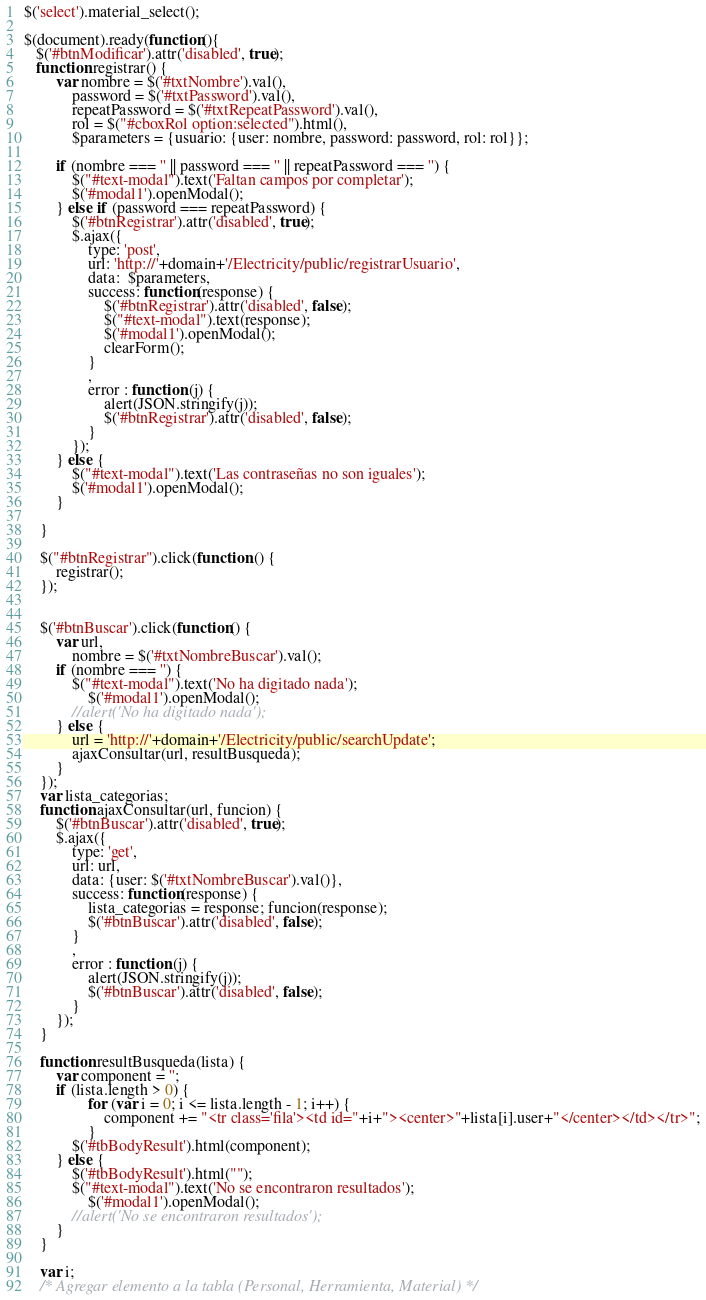Convert code to text. <code><loc_0><loc_0><loc_500><loc_500><_JavaScript_>$('select').material_select();

$(document).ready(function(){
   $('#btnModificar').attr('disabled', true);
   function registrar() {
        var nombre = $('#txtNombre').val(),
            password = $('#txtPassword').val(),
            repeatPassword = $('#txtRepeatPassword').val(),
            rol = $("#cboxRol option:selected").html(),
            $parameters = {usuario: {user: nombre, password: password, rol: rol}};
        
        if (nombre === '' || password === '' || repeatPassword === '') {
            $("#text-modal").text('Faltan campos por completar');
            $('#modal1').openModal();
        } else if (password === repeatPassword) {
            $('#btnRegistrar').attr('disabled', true);
            $.ajax({
                type: 'post',
                url: 'http://'+domain+'/Electricity/public/registrarUsuario',
                data:  $parameters, 
                success: function(response) {
                    $('#btnRegistrar').attr('disabled', false);
                    $("#text-modal").text(response);
                    $('#modal1').openModal();
                    clearForm();
                }
                ,
                error : function (j) {
                    alert(JSON.stringify(j));
                    $('#btnRegistrar').attr('disabled', false);
                }
            });
        } else {
            $("#text-modal").text('Las contraseñas no son iguales');
            $('#modal1').openModal();
        }
         
    } 
    
    $("#btnRegistrar").click(function () {
        registrar();
    });
    
    
    $('#btnBuscar').click(function() { 
        var url,
            nombre = $('#txtNombreBuscar').val();
        if (nombre === '') {
            $("#text-modal").text('No ha digitado nada');
                $('#modal1').openModal();
            //alert('No ha digitado nada');
        } else {   
            url = 'http://'+domain+'/Electricity/public/searchUpdate';
            ajaxConsultar(url, resultBusqueda);
        }
    });
    var lista_categorias;
    function ajaxConsultar(url, funcion) { 
        $('#btnBuscar').attr('disabled', true);
        $.ajax({
            type: 'get',
            url: url,
            data: {user: $('#txtNombreBuscar').val()},
            success: function(response) { 
                lista_categorias = response; funcion(response); 
                $('#btnBuscar').attr('disabled', false);
            }
            ,
            error : function (j) {
                alert(JSON.stringify(j));
                $('#btnBuscar').attr('disabled', false);
            }
        });
    }
    
    function resultBusqueda(lista) {
        var component = '';
        if (lista.length > 0) {
                for (var i = 0; i <= lista.length - 1; i++) {
                    component += "<tr class='fila'><td id="+i+"><center>"+lista[i].user+"</center></td></tr>";
                }
            $('#tbBodyResult').html(component);
        } else {
            $('#tbBodyResult').html("");
            $("#text-modal").text('No se encontraron resultados');
                $('#modal1').openModal();
            //alert('No se encontraron resultados');
        }    
    }
    
    var i;
    /* Agregar elemento a la tabla (Personal, Herramienta, Material) */</code> 